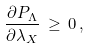Convert formula to latex. <formula><loc_0><loc_0><loc_500><loc_500>\frac { \partial P _ { \Lambda } } { \partial \lambda _ { X } } \, \geq \, 0 \, ,</formula> 